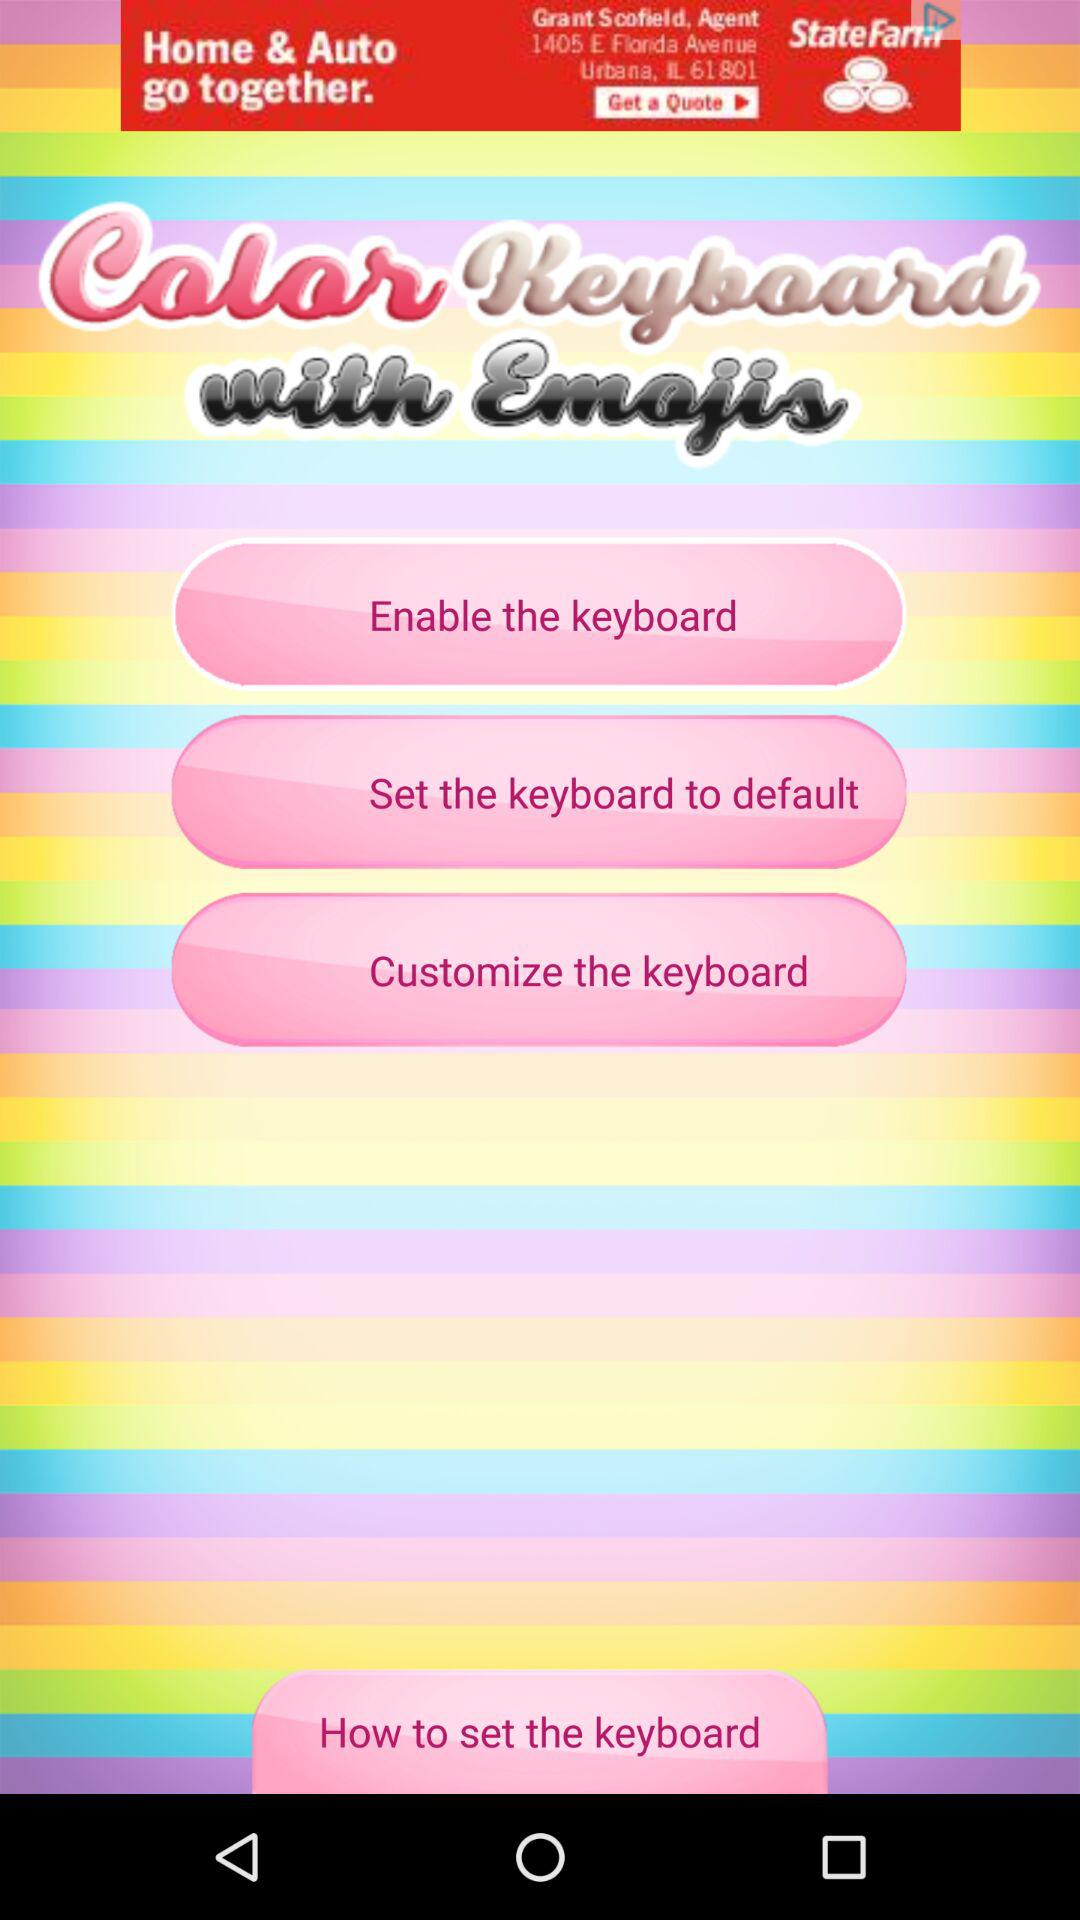What is the name of the application? The name of the application is "Color Keyboard with Emojis". 